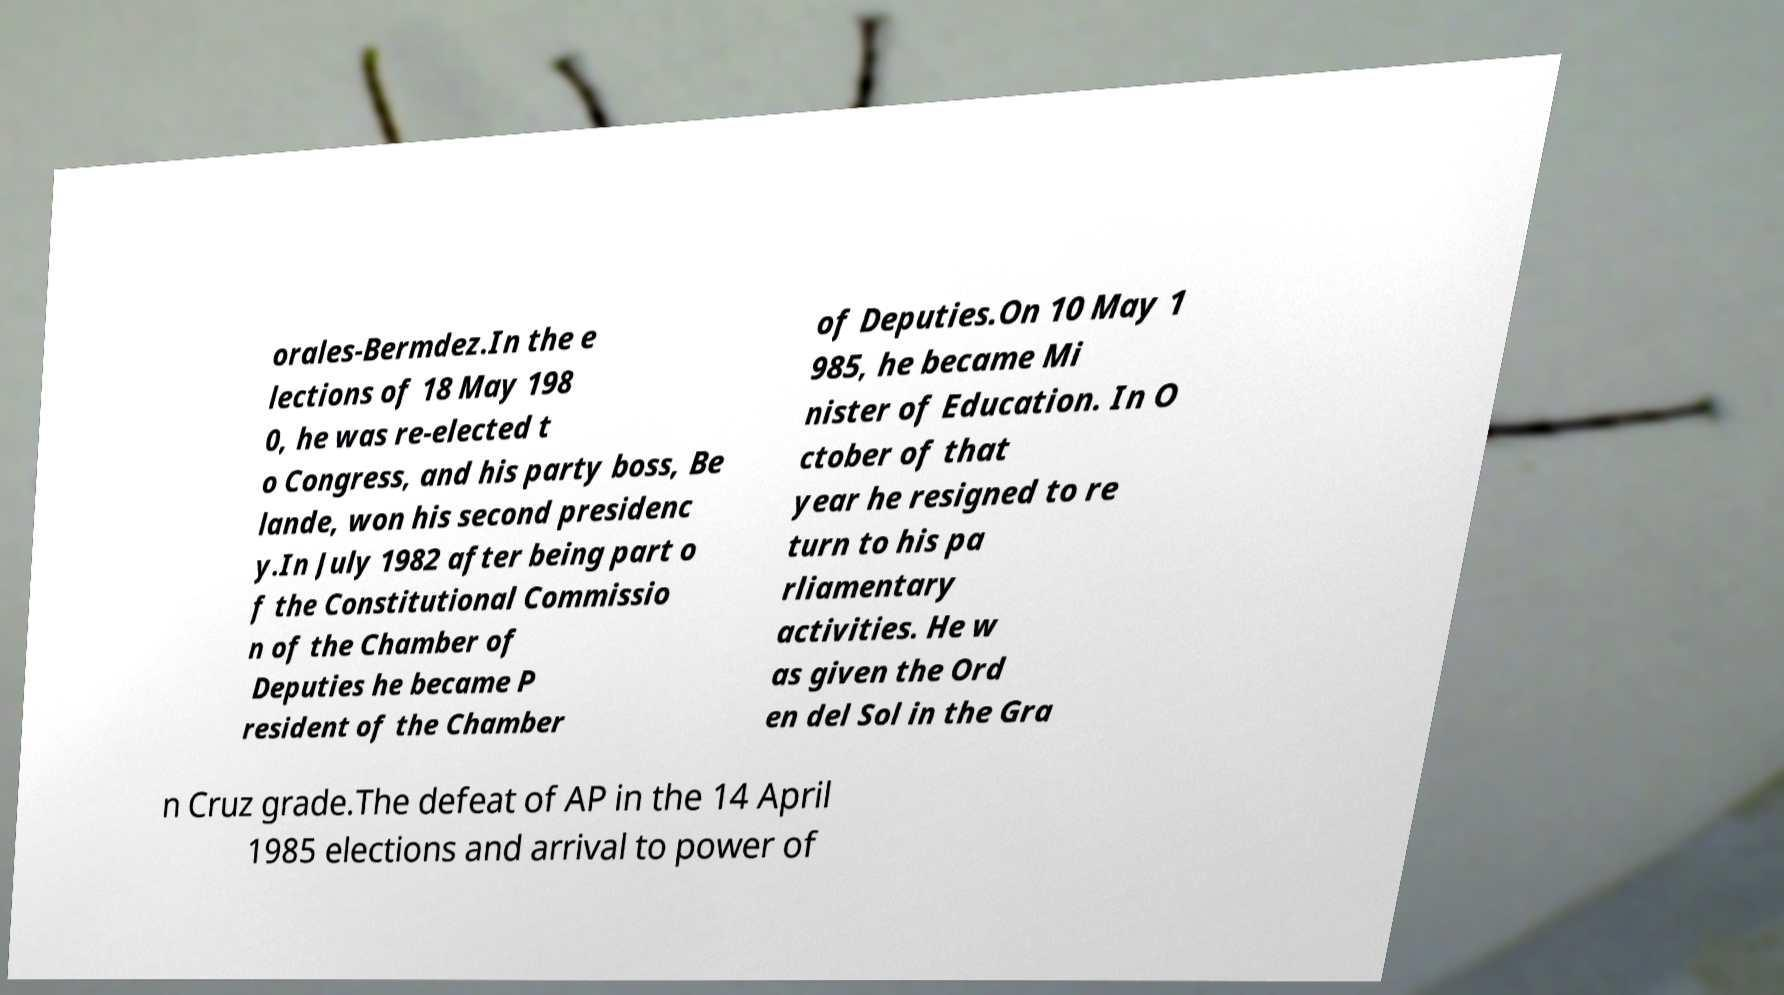Could you extract and type out the text from this image? orales-Bermdez.In the e lections of 18 May 198 0, he was re-elected t o Congress, and his party boss, Be lande, won his second presidenc y.In July 1982 after being part o f the Constitutional Commissio n of the Chamber of Deputies he became P resident of the Chamber of Deputies.On 10 May 1 985, he became Mi nister of Education. In O ctober of that year he resigned to re turn to his pa rliamentary activities. He w as given the Ord en del Sol in the Gra n Cruz grade.The defeat of AP in the 14 April 1985 elections and arrival to power of 